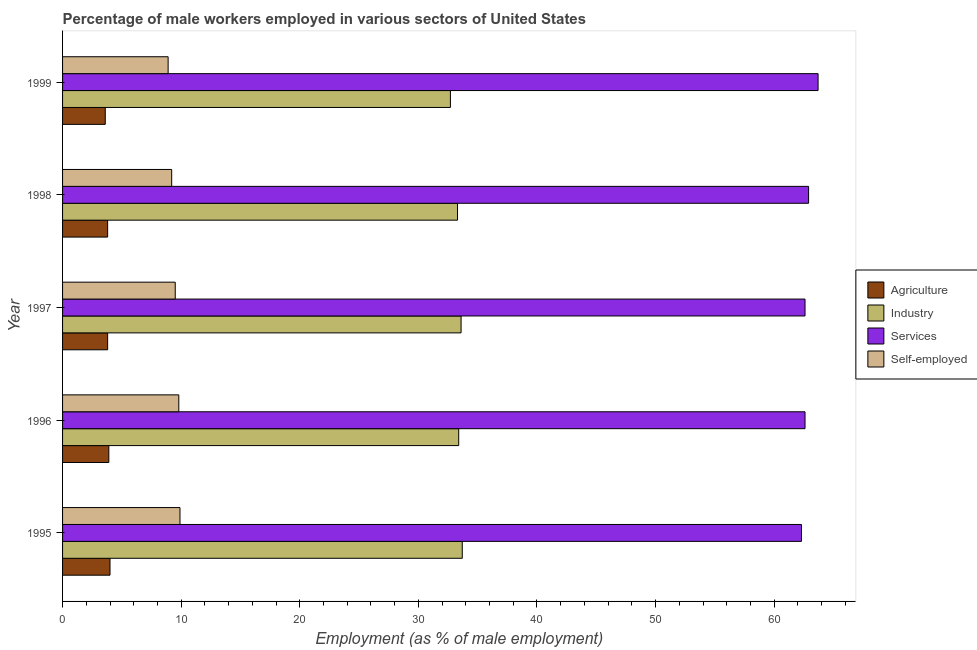How many different coloured bars are there?
Your answer should be compact. 4. How many groups of bars are there?
Your response must be concise. 5. Are the number of bars per tick equal to the number of legend labels?
Offer a very short reply. Yes. What is the label of the 5th group of bars from the top?
Provide a short and direct response. 1995. What is the percentage of male workers in services in 1997?
Offer a very short reply. 62.6. Across all years, what is the maximum percentage of male workers in industry?
Give a very brief answer. 33.7. Across all years, what is the minimum percentage of male workers in agriculture?
Offer a terse response. 3.6. In which year was the percentage of male workers in agriculture maximum?
Offer a terse response. 1995. In which year was the percentage of self employed male workers minimum?
Offer a terse response. 1999. What is the total percentage of male workers in agriculture in the graph?
Provide a succinct answer. 19.1. What is the difference between the percentage of male workers in industry in 1997 and that in 1998?
Provide a succinct answer. 0.3. What is the difference between the percentage of male workers in services in 1997 and the percentage of male workers in industry in 1995?
Ensure brevity in your answer.  28.9. What is the average percentage of male workers in agriculture per year?
Offer a terse response. 3.82. In the year 1998, what is the difference between the percentage of male workers in services and percentage of male workers in industry?
Offer a terse response. 29.6. In how many years, is the percentage of male workers in agriculture greater than the average percentage of male workers in agriculture taken over all years?
Provide a short and direct response. 2. Is the sum of the percentage of male workers in industry in 1996 and 1999 greater than the maximum percentage of male workers in agriculture across all years?
Ensure brevity in your answer.  Yes. Is it the case that in every year, the sum of the percentage of self employed male workers and percentage of male workers in services is greater than the sum of percentage of male workers in industry and percentage of male workers in agriculture?
Give a very brief answer. Yes. What does the 3rd bar from the top in 1996 represents?
Your answer should be compact. Industry. What does the 4th bar from the bottom in 1998 represents?
Keep it short and to the point. Self-employed. Is it the case that in every year, the sum of the percentage of male workers in agriculture and percentage of male workers in industry is greater than the percentage of male workers in services?
Your answer should be very brief. No. How many bars are there?
Offer a terse response. 20. How many years are there in the graph?
Make the answer very short. 5. Are the values on the major ticks of X-axis written in scientific E-notation?
Your answer should be very brief. No. Does the graph contain any zero values?
Your answer should be compact. No. Does the graph contain grids?
Your answer should be very brief. No. How many legend labels are there?
Your answer should be compact. 4. What is the title of the graph?
Keep it short and to the point. Percentage of male workers employed in various sectors of United States. What is the label or title of the X-axis?
Provide a succinct answer. Employment (as % of male employment). What is the label or title of the Y-axis?
Your response must be concise. Year. What is the Employment (as % of male employment) of Agriculture in 1995?
Make the answer very short. 4. What is the Employment (as % of male employment) in Industry in 1995?
Offer a very short reply. 33.7. What is the Employment (as % of male employment) of Services in 1995?
Your response must be concise. 62.3. What is the Employment (as % of male employment) of Self-employed in 1995?
Ensure brevity in your answer.  9.9. What is the Employment (as % of male employment) of Agriculture in 1996?
Offer a very short reply. 3.9. What is the Employment (as % of male employment) in Industry in 1996?
Offer a very short reply. 33.4. What is the Employment (as % of male employment) in Services in 1996?
Ensure brevity in your answer.  62.6. What is the Employment (as % of male employment) of Self-employed in 1996?
Provide a short and direct response. 9.8. What is the Employment (as % of male employment) in Agriculture in 1997?
Provide a succinct answer. 3.8. What is the Employment (as % of male employment) of Industry in 1997?
Your answer should be very brief. 33.6. What is the Employment (as % of male employment) in Services in 1997?
Your answer should be compact. 62.6. What is the Employment (as % of male employment) of Self-employed in 1997?
Make the answer very short. 9.5. What is the Employment (as % of male employment) of Agriculture in 1998?
Provide a short and direct response. 3.8. What is the Employment (as % of male employment) of Industry in 1998?
Make the answer very short. 33.3. What is the Employment (as % of male employment) in Services in 1998?
Your response must be concise. 62.9. What is the Employment (as % of male employment) in Self-employed in 1998?
Ensure brevity in your answer.  9.2. What is the Employment (as % of male employment) in Agriculture in 1999?
Give a very brief answer. 3.6. What is the Employment (as % of male employment) of Industry in 1999?
Keep it short and to the point. 32.7. What is the Employment (as % of male employment) in Services in 1999?
Your response must be concise. 63.7. What is the Employment (as % of male employment) in Self-employed in 1999?
Ensure brevity in your answer.  8.9. Across all years, what is the maximum Employment (as % of male employment) in Industry?
Make the answer very short. 33.7. Across all years, what is the maximum Employment (as % of male employment) of Services?
Ensure brevity in your answer.  63.7. Across all years, what is the maximum Employment (as % of male employment) in Self-employed?
Offer a terse response. 9.9. Across all years, what is the minimum Employment (as % of male employment) of Agriculture?
Provide a succinct answer. 3.6. Across all years, what is the minimum Employment (as % of male employment) in Industry?
Ensure brevity in your answer.  32.7. Across all years, what is the minimum Employment (as % of male employment) of Services?
Your answer should be very brief. 62.3. Across all years, what is the minimum Employment (as % of male employment) of Self-employed?
Provide a succinct answer. 8.9. What is the total Employment (as % of male employment) of Industry in the graph?
Ensure brevity in your answer.  166.7. What is the total Employment (as % of male employment) of Services in the graph?
Ensure brevity in your answer.  314.1. What is the total Employment (as % of male employment) in Self-employed in the graph?
Provide a short and direct response. 47.3. What is the difference between the Employment (as % of male employment) in Industry in 1995 and that in 1996?
Your response must be concise. 0.3. What is the difference between the Employment (as % of male employment) in Services in 1995 and that in 1996?
Your answer should be very brief. -0.3. What is the difference between the Employment (as % of male employment) of Industry in 1995 and that in 1998?
Your answer should be very brief. 0.4. What is the difference between the Employment (as % of male employment) of Self-employed in 1995 and that in 1998?
Offer a very short reply. 0.7. What is the difference between the Employment (as % of male employment) of Services in 1995 and that in 1999?
Your answer should be compact. -1.4. What is the difference between the Employment (as % of male employment) of Self-employed in 1995 and that in 1999?
Keep it short and to the point. 1. What is the difference between the Employment (as % of male employment) in Industry in 1996 and that in 1997?
Provide a succinct answer. -0.2. What is the difference between the Employment (as % of male employment) of Agriculture in 1996 and that in 1998?
Your answer should be very brief. 0.1. What is the difference between the Employment (as % of male employment) of Industry in 1996 and that in 1998?
Give a very brief answer. 0.1. What is the difference between the Employment (as % of male employment) of Self-employed in 1996 and that in 1998?
Offer a terse response. 0.6. What is the difference between the Employment (as % of male employment) of Industry in 1996 and that in 1999?
Offer a very short reply. 0.7. What is the difference between the Employment (as % of male employment) of Self-employed in 1996 and that in 1999?
Your answer should be compact. 0.9. What is the difference between the Employment (as % of male employment) of Agriculture in 1997 and that in 1998?
Your answer should be compact. 0. What is the difference between the Employment (as % of male employment) of Industry in 1997 and that in 1998?
Offer a terse response. 0.3. What is the difference between the Employment (as % of male employment) of Agriculture in 1997 and that in 1999?
Your response must be concise. 0.2. What is the difference between the Employment (as % of male employment) in Industry in 1997 and that in 1999?
Provide a short and direct response. 0.9. What is the difference between the Employment (as % of male employment) in Services in 1997 and that in 1999?
Ensure brevity in your answer.  -1.1. What is the difference between the Employment (as % of male employment) in Self-employed in 1997 and that in 1999?
Provide a short and direct response. 0.6. What is the difference between the Employment (as % of male employment) in Services in 1998 and that in 1999?
Provide a succinct answer. -0.8. What is the difference between the Employment (as % of male employment) in Self-employed in 1998 and that in 1999?
Keep it short and to the point. 0.3. What is the difference between the Employment (as % of male employment) in Agriculture in 1995 and the Employment (as % of male employment) in Industry in 1996?
Provide a succinct answer. -29.4. What is the difference between the Employment (as % of male employment) in Agriculture in 1995 and the Employment (as % of male employment) in Services in 1996?
Your response must be concise. -58.6. What is the difference between the Employment (as % of male employment) in Industry in 1995 and the Employment (as % of male employment) in Services in 1996?
Offer a very short reply. -28.9. What is the difference between the Employment (as % of male employment) in Industry in 1995 and the Employment (as % of male employment) in Self-employed in 1996?
Keep it short and to the point. 23.9. What is the difference between the Employment (as % of male employment) in Services in 1995 and the Employment (as % of male employment) in Self-employed in 1996?
Ensure brevity in your answer.  52.5. What is the difference between the Employment (as % of male employment) of Agriculture in 1995 and the Employment (as % of male employment) of Industry in 1997?
Offer a very short reply. -29.6. What is the difference between the Employment (as % of male employment) of Agriculture in 1995 and the Employment (as % of male employment) of Services in 1997?
Your response must be concise. -58.6. What is the difference between the Employment (as % of male employment) in Industry in 1995 and the Employment (as % of male employment) in Services in 1997?
Make the answer very short. -28.9. What is the difference between the Employment (as % of male employment) of Industry in 1995 and the Employment (as % of male employment) of Self-employed in 1997?
Your answer should be compact. 24.2. What is the difference between the Employment (as % of male employment) of Services in 1995 and the Employment (as % of male employment) of Self-employed in 1997?
Make the answer very short. 52.8. What is the difference between the Employment (as % of male employment) in Agriculture in 1995 and the Employment (as % of male employment) in Industry in 1998?
Provide a short and direct response. -29.3. What is the difference between the Employment (as % of male employment) in Agriculture in 1995 and the Employment (as % of male employment) in Services in 1998?
Your response must be concise. -58.9. What is the difference between the Employment (as % of male employment) of Agriculture in 1995 and the Employment (as % of male employment) of Self-employed in 1998?
Your response must be concise. -5.2. What is the difference between the Employment (as % of male employment) of Industry in 1995 and the Employment (as % of male employment) of Services in 1998?
Provide a short and direct response. -29.2. What is the difference between the Employment (as % of male employment) of Services in 1995 and the Employment (as % of male employment) of Self-employed in 1998?
Offer a terse response. 53.1. What is the difference between the Employment (as % of male employment) in Agriculture in 1995 and the Employment (as % of male employment) in Industry in 1999?
Offer a very short reply. -28.7. What is the difference between the Employment (as % of male employment) in Agriculture in 1995 and the Employment (as % of male employment) in Services in 1999?
Make the answer very short. -59.7. What is the difference between the Employment (as % of male employment) in Industry in 1995 and the Employment (as % of male employment) in Services in 1999?
Your answer should be compact. -30. What is the difference between the Employment (as % of male employment) of Industry in 1995 and the Employment (as % of male employment) of Self-employed in 1999?
Your answer should be very brief. 24.8. What is the difference between the Employment (as % of male employment) of Services in 1995 and the Employment (as % of male employment) of Self-employed in 1999?
Give a very brief answer. 53.4. What is the difference between the Employment (as % of male employment) in Agriculture in 1996 and the Employment (as % of male employment) in Industry in 1997?
Your answer should be very brief. -29.7. What is the difference between the Employment (as % of male employment) of Agriculture in 1996 and the Employment (as % of male employment) of Services in 1997?
Provide a short and direct response. -58.7. What is the difference between the Employment (as % of male employment) of Agriculture in 1996 and the Employment (as % of male employment) of Self-employed in 1997?
Make the answer very short. -5.6. What is the difference between the Employment (as % of male employment) of Industry in 1996 and the Employment (as % of male employment) of Services in 1997?
Make the answer very short. -29.2. What is the difference between the Employment (as % of male employment) in Industry in 1996 and the Employment (as % of male employment) in Self-employed in 1997?
Provide a short and direct response. 23.9. What is the difference between the Employment (as % of male employment) of Services in 1996 and the Employment (as % of male employment) of Self-employed in 1997?
Provide a succinct answer. 53.1. What is the difference between the Employment (as % of male employment) of Agriculture in 1996 and the Employment (as % of male employment) of Industry in 1998?
Provide a short and direct response. -29.4. What is the difference between the Employment (as % of male employment) in Agriculture in 1996 and the Employment (as % of male employment) in Services in 1998?
Provide a succinct answer. -59. What is the difference between the Employment (as % of male employment) of Agriculture in 1996 and the Employment (as % of male employment) of Self-employed in 1998?
Provide a short and direct response. -5.3. What is the difference between the Employment (as % of male employment) of Industry in 1996 and the Employment (as % of male employment) of Services in 1998?
Your answer should be very brief. -29.5. What is the difference between the Employment (as % of male employment) in Industry in 1996 and the Employment (as % of male employment) in Self-employed in 1998?
Provide a short and direct response. 24.2. What is the difference between the Employment (as % of male employment) in Services in 1996 and the Employment (as % of male employment) in Self-employed in 1998?
Provide a succinct answer. 53.4. What is the difference between the Employment (as % of male employment) of Agriculture in 1996 and the Employment (as % of male employment) of Industry in 1999?
Make the answer very short. -28.8. What is the difference between the Employment (as % of male employment) in Agriculture in 1996 and the Employment (as % of male employment) in Services in 1999?
Ensure brevity in your answer.  -59.8. What is the difference between the Employment (as % of male employment) in Industry in 1996 and the Employment (as % of male employment) in Services in 1999?
Give a very brief answer. -30.3. What is the difference between the Employment (as % of male employment) of Services in 1996 and the Employment (as % of male employment) of Self-employed in 1999?
Your answer should be compact. 53.7. What is the difference between the Employment (as % of male employment) in Agriculture in 1997 and the Employment (as % of male employment) in Industry in 1998?
Provide a short and direct response. -29.5. What is the difference between the Employment (as % of male employment) of Agriculture in 1997 and the Employment (as % of male employment) of Services in 1998?
Provide a short and direct response. -59.1. What is the difference between the Employment (as % of male employment) of Agriculture in 1997 and the Employment (as % of male employment) of Self-employed in 1998?
Ensure brevity in your answer.  -5.4. What is the difference between the Employment (as % of male employment) in Industry in 1997 and the Employment (as % of male employment) in Services in 1998?
Make the answer very short. -29.3. What is the difference between the Employment (as % of male employment) of Industry in 1997 and the Employment (as % of male employment) of Self-employed in 1998?
Offer a very short reply. 24.4. What is the difference between the Employment (as % of male employment) of Services in 1997 and the Employment (as % of male employment) of Self-employed in 1998?
Provide a succinct answer. 53.4. What is the difference between the Employment (as % of male employment) of Agriculture in 1997 and the Employment (as % of male employment) of Industry in 1999?
Your answer should be very brief. -28.9. What is the difference between the Employment (as % of male employment) of Agriculture in 1997 and the Employment (as % of male employment) of Services in 1999?
Your response must be concise. -59.9. What is the difference between the Employment (as % of male employment) in Industry in 1997 and the Employment (as % of male employment) in Services in 1999?
Your response must be concise. -30.1. What is the difference between the Employment (as % of male employment) of Industry in 1997 and the Employment (as % of male employment) of Self-employed in 1999?
Your response must be concise. 24.7. What is the difference between the Employment (as % of male employment) in Services in 1997 and the Employment (as % of male employment) in Self-employed in 1999?
Keep it short and to the point. 53.7. What is the difference between the Employment (as % of male employment) in Agriculture in 1998 and the Employment (as % of male employment) in Industry in 1999?
Your answer should be compact. -28.9. What is the difference between the Employment (as % of male employment) in Agriculture in 1998 and the Employment (as % of male employment) in Services in 1999?
Provide a short and direct response. -59.9. What is the difference between the Employment (as % of male employment) in Agriculture in 1998 and the Employment (as % of male employment) in Self-employed in 1999?
Provide a short and direct response. -5.1. What is the difference between the Employment (as % of male employment) in Industry in 1998 and the Employment (as % of male employment) in Services in 1999?
Ensure brevity in your answer.  -30.4. What is the difference between the Employment (as % of male employment) of Industry in 1998 and the Employment (as % of male employment) of Self-employed in 1999?
Your answer should be very brief. 24.4. What is the average Employment (as % of male employment) of Agriculture per year?
Your answer should be compact. 3.82. What is the average Employment (as % of male employment) of Industry per year?
Keep it short and to the point. 33.34. What is the average Employment (as % of male employment) in Services per year?
Ensure brevity in your answer.  62.82. What is the average Employment (as % of male employment) of Self-employed per year?
Offer a terse response. 9.46. In the year 1995, what is the difference between the Employment (as % of male employment) of Agriculture and Employment (as % of male employment) of Industry?
Make the answer very short. -29.7. In the year 1995, what is the difference between the Employment (as % of male employment) in Agriculture and Employment (as % of male employment) in Services?
Ensure brevity in your answer.  -58.3. In the year 1995, what is the difference between the Employment (as % of male employment) of Industry and Employment (as % of male employment) of Services?
Offer a terse response. -28.6. In the year 1995, what is the difference between the Employment (as % of male employment) of Industry and Employment (as % of male employment) of Self-employed?
Your response must be concise. 23.8. In the year 1995, what is the difference between the Employment (as % of male employment) in Services and Employment (as % of male employment) in Self-employed?
Make the answer very short. 52.4. In the year 1996, what is the difference between the Employment (as % of male employment) of Agriculture and Employment (as % of male employment) of Industry?
Provide a succinct answer. -29.5. In the year 1996, what is the difference between the Employment (as % of male employment) in Agriculture and Employment (as % of male employment) in Services?
Your answer should be very brief. -58.7. In the year 1996, what is the difference between the Employment (as % of male employment) of Industry and Employment (as % of male employment) of Services?
Offer a terse response. -29.2. In the year 1996, what is the difference between the Employment (as % of male employment) of Industry and Employment (as % of male employment) of Self-employed?
Offer a terse response. 23.6. In the year 1996, what is the difference between the Employment (as % of male employment) in Services and Employment (as % of male employment) in Self-employed?
Provide a succinct answer. 52.8. In the year 1997, what is the difference between the Employment (as % of male employment) in Agriculture and Employment (as % of male employment) in Industry?
Provide a short and direct response. -29.8. In the year 1997, what is the difference between the Employment (as % of male employment) in Agriculture and Employment (as % of male employment) in Services?
Give a very brief answer. -58.8. In the year 1997, what is the difference between the Employment (as % of male employment) of Industry and Employment (as % of male employment) of Services?
Your answer should be very brief. -29. In the year 1997, what is the difference between the Employment (as % of male employment) in Industry and Employment (as % of male employment) in Self-employed?
Your answer should be very brief. 24.1. In the year 1997, what is the difference between the Employment (as % of male employment) in Services and Employment (as % of male employment) in Self-employed?
Keep it short and to the point. 53.1. In the year 1998, what is the difference between the Employment (as % of male employment) in Agriculture and Employment (as % of male employment) in Industry?
Give a very brief answer. -29.5. In the year 1998, what is the difference between the Employment (as % of male employment) of Agriculture and Employment (as % of male employment) of Services?
Keep it short and to the point. -59.1. In the year 1998, what is the difference between the Employment (as % of male employment) of Industry and Employment (as % of male employment) of Services?
Offer a terse response. -29.6. In the year 1998, what is the difference between the Employment (as % of male employment) in Industry and Employment (as % of male employment) in Self-employed?
Make the answer very short. 24.1. In the year 1998, what is the difference between the Employment (as % of male employment) in Services and Employment (as % of male employment) in Self-employed?
Offer a terse response. 53.7. In the year 1999, what is the difference between the Employment (as % of male employment) in Agriculture and Employment (as % of male employment) in Industry?
Your answer should be compact. -29.1. In the year 1999, what is the difference between the Employment (as % of male employment) in Agriculture and Employment (as % of male employment) in Services?
Provide a short and direct response. -60.1. In the year 1999, what is the difference between the Employment (as % of male employment) in Industry and Employment (as % of male employment) in Services?
Provide a succinct answer. -31. In the year 1999, what is the difference between the Employment (as % of male employment) in Industry and Employment (as % of male employment) in Self-employed?
Your response must be concise. 23.8. In the year 1999, what is the difference between the Employment (as % of male employment) of Services and Employment (as % of male employment) of Self-employed?
Your response must be concise. 54.8. What is the ratio of the Employment (as % of male employment) in Agriculture in 1995 to that in 1996?
Offer a terse response. 1.03. What is the ratio of the Employment (as % of male employment) of Self-employed in 1995 to that in 1996?
Offer a very short reply. 1.01. What is the ratio of the Employment (as % of male employment) in Agriculture in 1995 to that in 1997?
Your answer should be compact. 1.05. What is the ratio of the Employment (as % of male employment) of Industry in 1995 to that in 1997?
Give a very brief answer. 1. What is the ratio of the Employment (as % of male employment) of Services in 1995 to that in 1997?
Offer a very short reply. 1. What is the ratio of the Employment (as % of male employment) in Self-employed in 1995 to that in 1997?
Your answer should be very brief. 1.04. What is the ratio of the Employment (as % of male employment) in Agriculture in 1995 to that in 1998?
Make the answer very short. 1.05. What is the ratio of the Employment (as % of male employment) in Industry in 1995 to that in 1998?
Ensure brevity in your answer.  1.01. What is the ratio of the Employment (as % of male employment) of Services in 1995 to that in 1998?
Make the answer very short. 0.99. What is the ratio of the Employment (as % of male employment) of Self-employed in 1995 to that in 1998?
Provide a short and direct response. 1.08. What is the ratio of the Employment (as % of male employment) in Industry in 1995 to that in 1999?
Offer a very short reply. 1.03. What is the ratio of the Employment (as % of male employment) of Services in 1995 to that in 1999?
Offer a very short reply. 0.98. What is the ratio of the Employment (as % of male employment) of Self-employed in 1995 to that in 1999?
Keep it short and to the point. 1.11. What is the ratio of the Employment (as % of male employment) of Agriculture in 1996 to that in 1997?
Give a very brief answer. 1.03. What is the ratio of the Employment (as % of male employment) in Self-employed in 1996 to that in 1997?
Keep it short and to the point. 1.03. What is the ratio of the Employment (as % of male employment) of Agriculture in 1996 to that in 1998?
Give a very brief answer. 1.03. What is the ratio of the Employment (as % of male employment) in Industry in 1996 to that in 1998?
Your response must be concise. 1. What is the ratio of the Employment (as % of male employment) in Services in 1996 to that in 1998?
Your answer should be compact. 1. What is the ratio of the Employment (as % of male employment) in Self-employed in 1996 to that in 1998?
Ensure brevity in your answer.  1.07. What is the ratio of the Employment (as % of male employment) of Industry in 1996 to that in 1999?
Offer a terse response. 1.02. What is the ratio of the Employment (as % of male employment) in Services in 1996 to that in 1999?
Your answer should be very brief. 0.98. What is the ratio of the Employment (as % of male employment) in Self-employed in 1996 to that in 1999?
Offer a terse response. 1.1. What is the ratio of the Employment (as % of male employment) of Agriculture in 1997 to that in 1998?
Ensure brevity in your answer.  1. What is the ratio of the Employment (as % of male employment) in Services in 1997 to that in 1998?
Keep it short and to the point. 1. What is the ratio of the Employment (as % of male employment) in Self-employed in 1997 to that in 1998?
Offer a very short reply. 1.03. What is the ratio of the Employment (as % of male employment) in Agriculture in 1997 to that in 1999?
Your response must be concise. 1.06. What is the ratio of the Employment (as % of male employment) in Industry in 1997 to that in 1999?
Give a very brief answer. 1.03. What is the ratio of the Employment (as % of male employment) of Services in 1997 to that in 1999?
Keep it short and to the point. 0.98. What is the ratio of the Employment (as % of male employment) in Self-employed in 1997 to that in 1999?
Your response must be concise. 1.07. What is the ratio of the Employment (as % of male employment) of Agriculture in 1998 to that in 1999?
Provide a short and direct response. 1.06. What is the ratio of the Employment (as % of male employment) of Industry in 1998 to that in 1999?
Offer a terse response. 1.02. What is the ratio of the Employment (as % of male employment) in Services in 1998 to that in 1999?
Ensure brevity in your answer.  0.99. What is the ratio of the Employment (as % of male employment) in Self-employed in 1998 to that in 1999?
Keep it short and to the point. 1.03. What is the difference between the highest and the second highest Employment (as % of male employment) of Agriculture?
Provide a succinct answer. 0.1. What is the difference between the highest and the second highest Employment (as % of male employment) of Self-employed?
Provide a succinct answer. 0.1. 